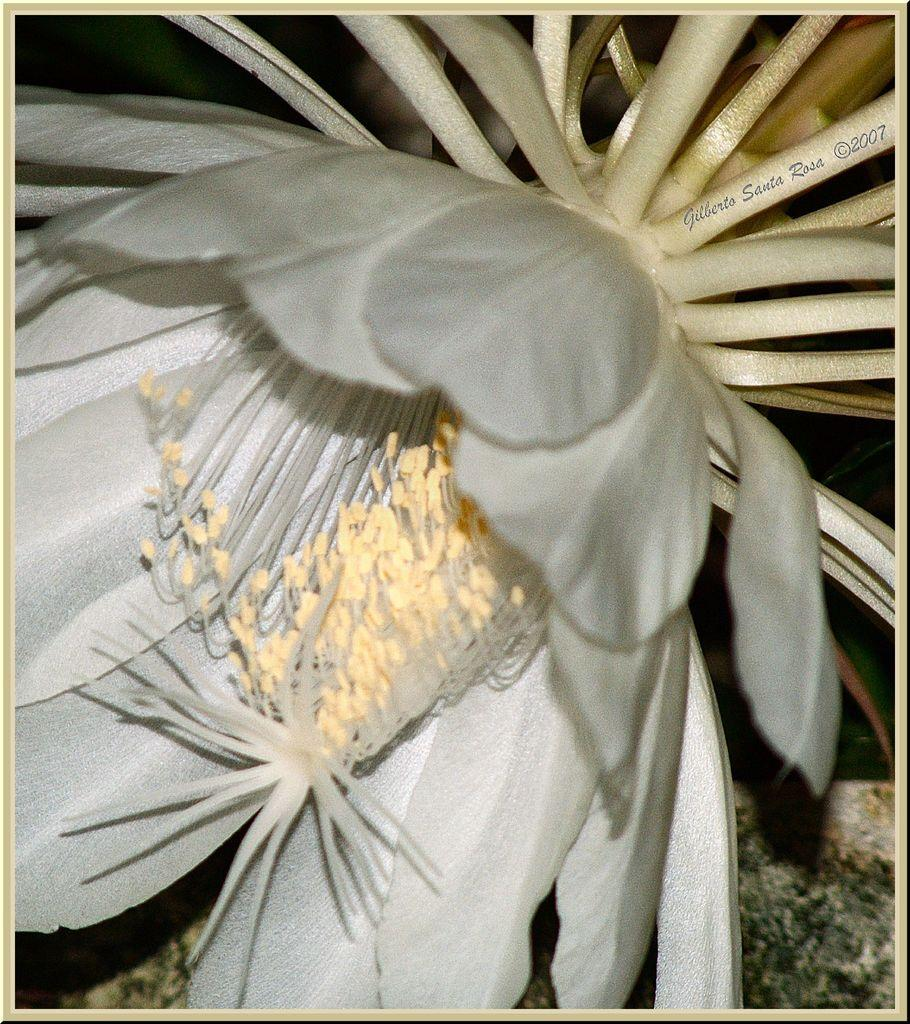What is the main subject of the image? There is a flower in the image. What else can be seen in the image besides the flower? There is text in the top right corner of the image. What is visible at the bottom of the image? The ground is visible at the bottom of the image. Can you tell me how many men are holding crayons in the image? There are no men or crayons present in the image; it features a flower and text. 